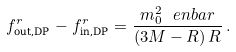<formula> <loc_0><loc_0><loc_500><loc_500>f ^ { r } _ { \text {out,DP} } - f ^ { r } _ { \text {in,DP} } = \frac { m _ { 0 } ^ { 2 } \ e n b a r } { \left ( 3 M - R \right ) R } \, .</formula> 